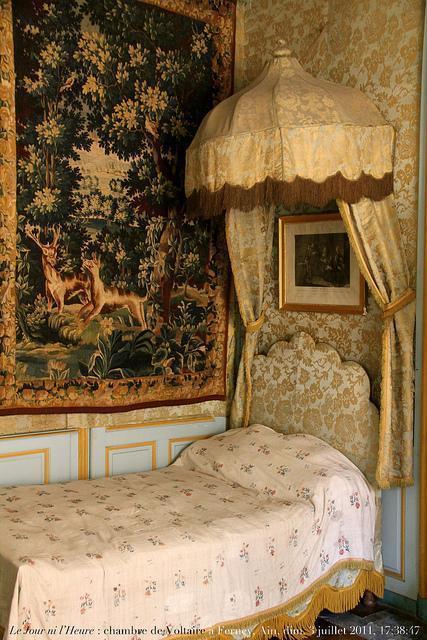How many people are holding signs?
Give a very brief answer. 0. 